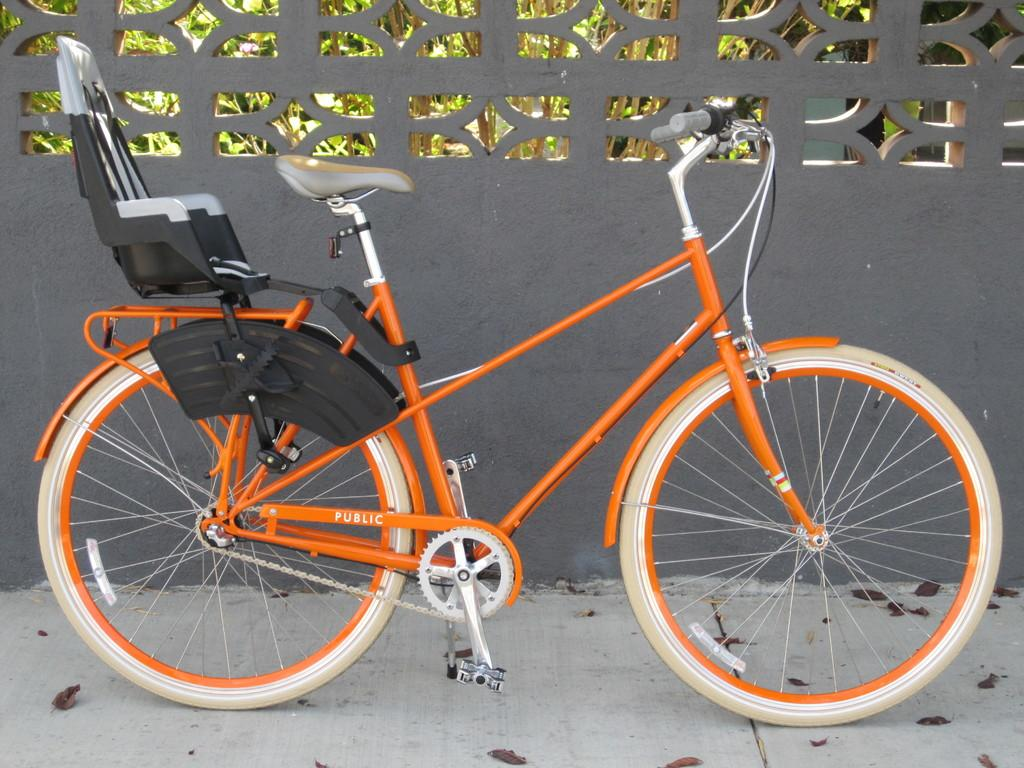What is the main object in the image? There is a bicycle in the image. What can be seen on the ground in the image? Dried leaves are present on the ground. What type of barrier is visible in the image? There is a fence in the image. What is visible in the background of the image? Trees are visible in the background of the image. What type of hair can be seen on the loaf in the image? There is no loaf or hair present in the image. 